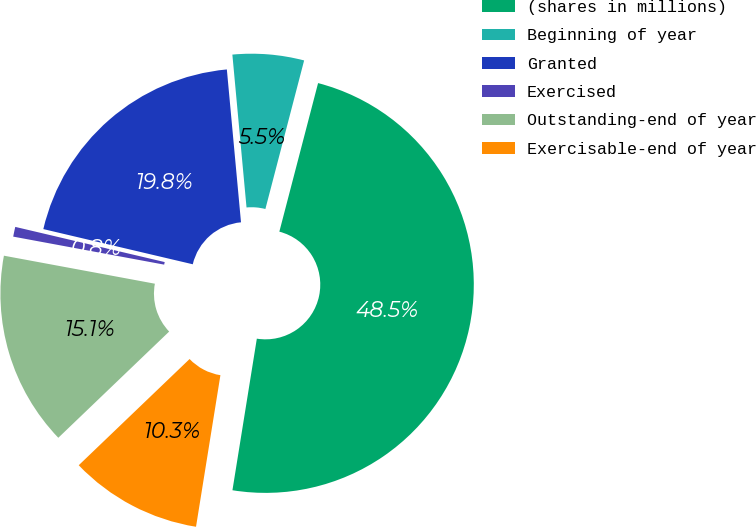Convert chart to OTSL. <chart><loc_0><loc_0><loc_500><loc_500><pie_chart><fcel>(shares in millions)<fcel>Beginning of year<fcel>Granted<fcel>Exercised<fcel>Outstanding-end of year<fcel>Exercisable-end of year<nl><fcel>48.48%<fcel>5.53%<fcel>19.85%<fcel>0.76%<fcel>15.08%<fcel>10.3%<nl></chart> 